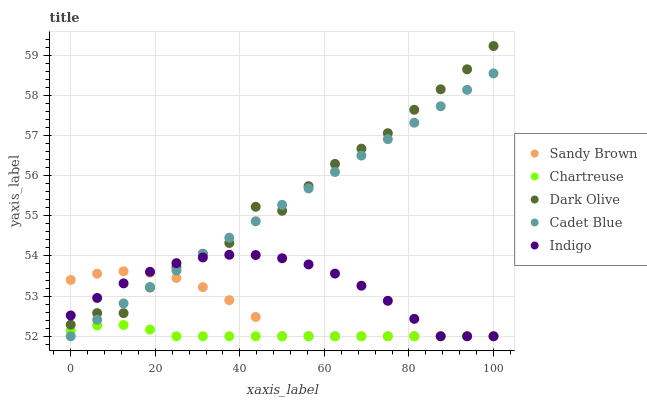Does Chartreuse have the minimum area under the curve?
Answer yes or no. Yes. Does Dark Olive have the maximum area under the curve?
Answer yes or no. Yes. Does Indigo have the minimum area under the curve?
Answer yes or no. No. Does Indigo have the maximum area under the curve?
Answer yes or no. No. Is Cadet Blue the smoothest?
Answer yes or no. Yes. Is Dark Olive the roughest?
Answer yes or no. Yes. Is Indigo the smoothest?
Answer yes or no. No. Is Indigo the roughest?
Answer yes or no. No. Does Cadet Blue have the lowest value?
Answer yes or no. Yes. Does Dark Olive have the lowest value?
Answer yes or no. No. Does Dark Olive have the highest value?
Answer yes or no. Yes. Does Indigo have the highest value?
Answer yes or no. No. Is Chartreuse less than Dark Olive?
Answer yes or no. Yes. Is Dark Olive greater than Chartreuse?
Answer yes or no. Yes. Does Dark Olive intersect Sandy Brown?
Answer yes or no. Yes. Is Dark Olive less than Sandy Brown?
Answer yes or no. No. Is Dark Olive greater than Sandy Brown?
Answer yes or no. No. Does Chartreuse intersect Dark Olive?
Answer yes or no. No. 